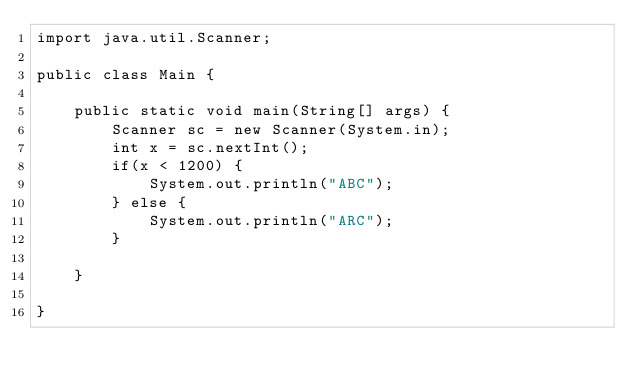<code> <loc_0><loc_0><loc_500><loc_500><_Java_>import java.util.Scanner;

public class Main {

	public static void main(String[] args) {
		Scanner sc = new Scanner(System.in);
		int x = sc.nextInt();
		if(x < 1200) {
			System.out.println("ABC");
		} else {
			System.out.println("ARC");
		}

	}

}
</code> 